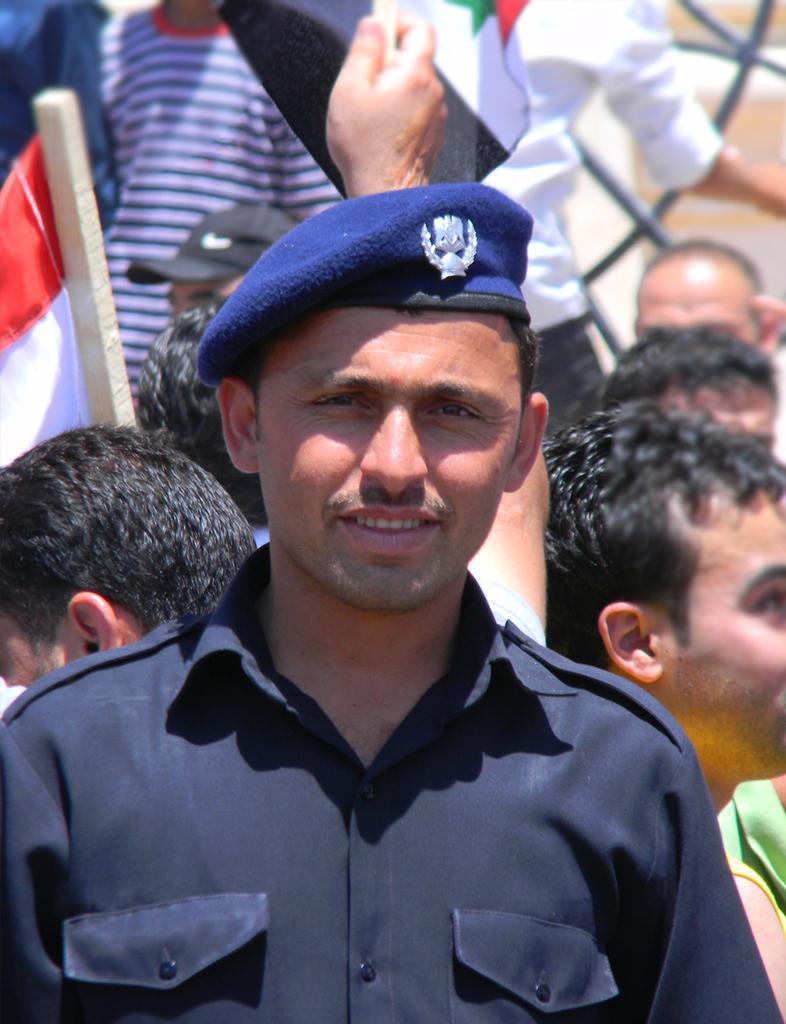Can you describe this image briefly? In the center of the image there is a man with uniform and a blue cap. In the background there are few more persons. There is also a flag to the wooden stick. 